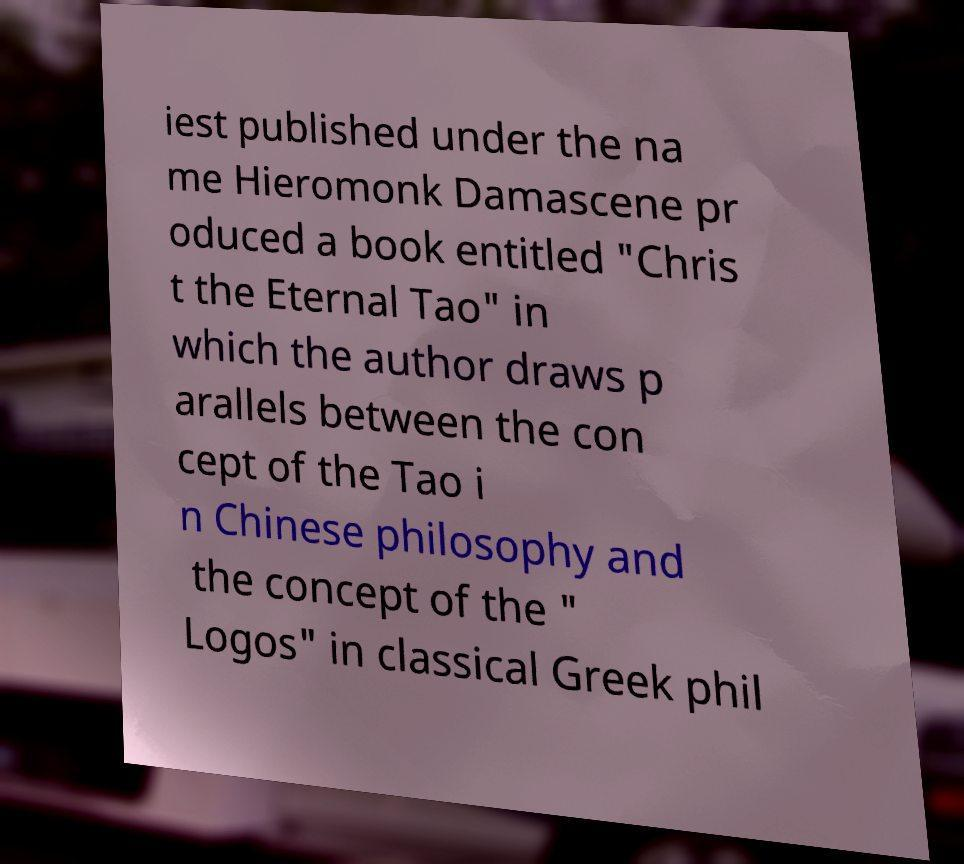Can you accurately transcribe the text from the provided image for me? iest published under the na me Hieromonk Damascene pr oduced a book entitled "Chris t the Eternal Tao" in which the author draws p arallels between the con cept of the Tao i n Chinese philosophy and the concept of the " Logos" in classical Greek phil 